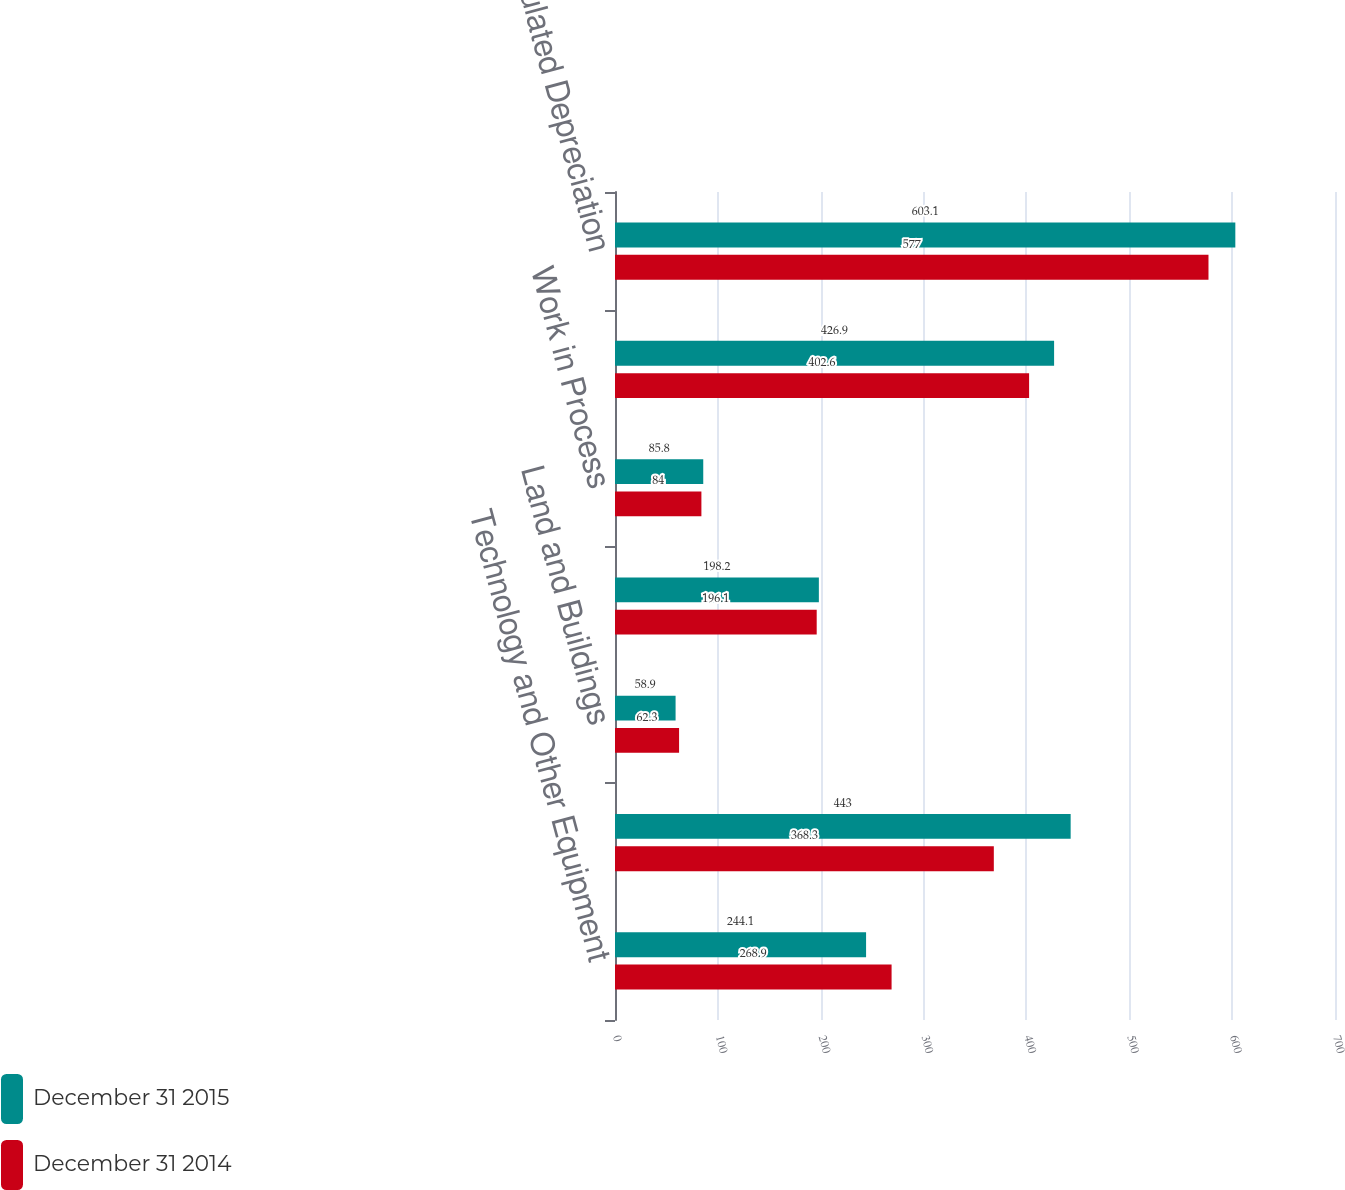Convert chart to OTSL. <chart><loc_0><loc_0><loc_500><loc_500><stacked_bar_chart><ecel><fcel>Technology and Other Equipment<fcel>Software<fcel>Land and Buildings<fcel>Leasehold Improvements<fcel>Work in Process<fcel>Property Equipment and<fcel>Less Accumulated Depreciation<nl><fcel>December 31 2015<fcel>244.1<fcel>443<fcel>58.9<fcel>198.2<fcel>85.8<fcel>426.9<fcel>603.1<nl><fcel>December 31 2014<fcel>268.9<fcel>368.3<fcel>62.3<fcel>196.1<fcel>84<fcel>402.6<fcel>577<nl></chart> 